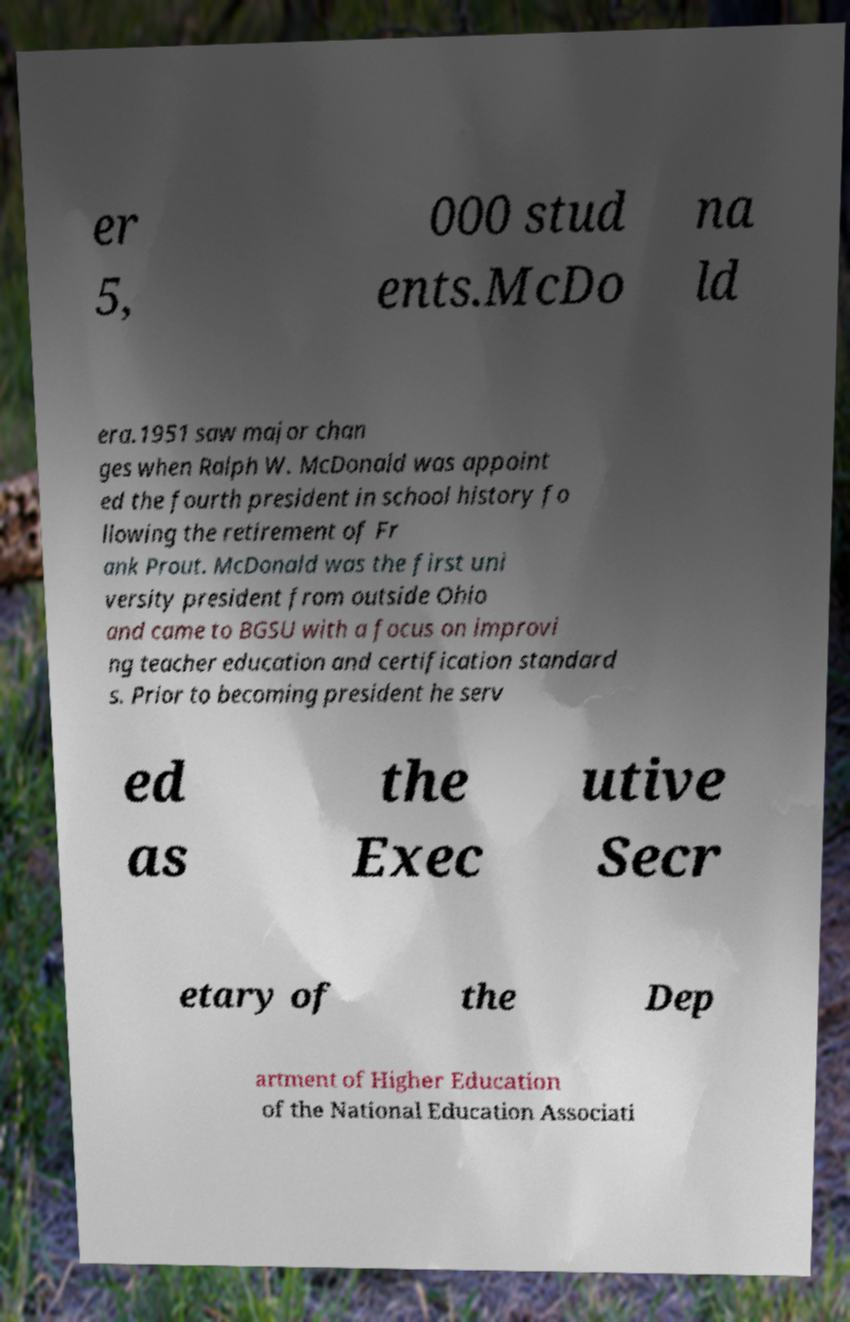Please identify and transcribe the text found in this image. er 5, 000 stud ents.McDo na ld era.1951 saw major chan ges when Ralph W. McDonald was appoint ed the fourth president in school history fo llowing the retirement of Fr ank Prout. McDonald was the first uni versity president from outside Ohio and came to BGSU with a focus on improvi ng teacher education and certification standard s. Prior to becoming president he serv ed as the Exec utive Secr etary of the Dep artment of Higher Education of the National Education Associati 